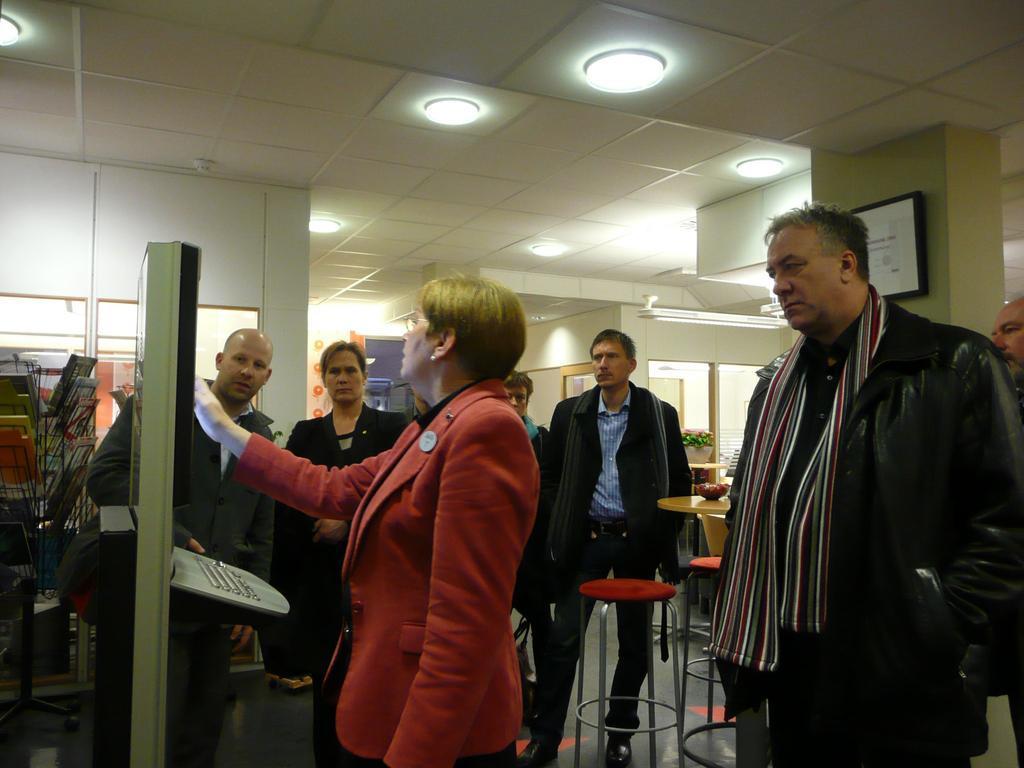Please provide a concise description of this image. In the center of the image there is a person standing in front of some object. Beside her there are few other people standing on the floor. There are chairs. There is a table. On top of it there is a flower pot. In the background of the image there is a door. There is a wall. On the left side of the image there are some objects. On top of the image there are light. On the right side of the image there is a photo frame on the wall. 